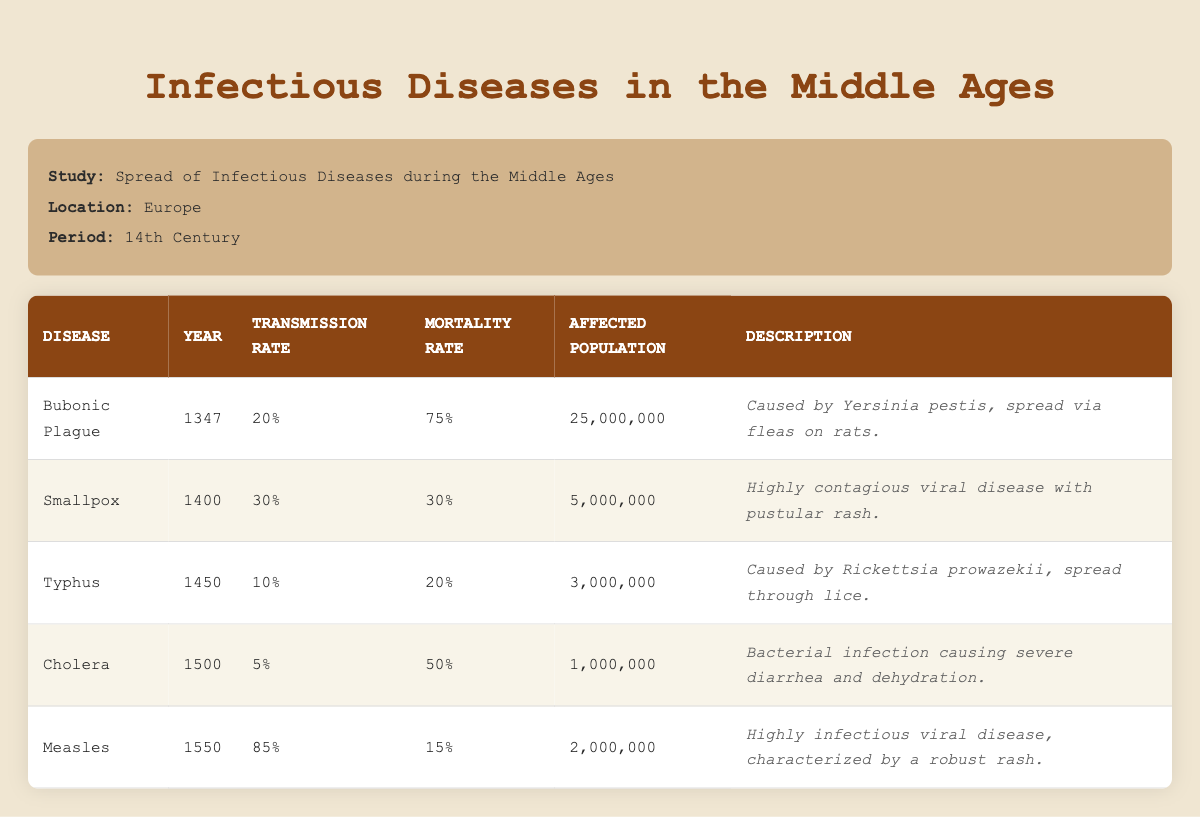What disease had the highest transmission rate during the Middle Ages? Looking at the transmission rates in the table, the disease with the highest transmission rate is Measles at 85%.
Answer: Measles What was the mortality rate of the Bubonic Plague? Referring to the table, the mortality rate for the Bubonic Plague is 75%.
Answer: 75% How many people were affected by Smallpox? The affected population for Smallpox is listed in the table as 5,000,000.
Answer: 5,000,000 Did Typhus have a higher or lower mortality rate than Cholera? Typhus had a mortality rate of 20% while Cholera had a rate of 50%. Since 20% is less than 50%, Typhus had a lower mortality rate than Cholera.
Answer: Lower What is the difference in affected population between the Bubonic Plague and Cholera? The affected population for the Bubonic Plague is 25,000,000 and for Cholera, it is 1,000,000. Calculating the difference: 25,000,000 - 1,000,000 = 24,000,000.
Answer: 24,000,000 What was the average affected population for all diseases listed? To find the average, we need to sum the affected populations: 25,000,000 + 5,000,000 + 3,000,000 + 1,000,000 + 2,000,000 = 36,000,000. There are 5 diseases, so the average is 36,000,000 / 5 = 7,200,000.
Answer: 7,200,000 Was Cholera spread through rats? According to the descriptions in the table, Cholera is a bacterial infection spread causing severe diarrhea and dehydration, but it does not mention rats. Bubonic Plague is noted for spreading via fleas on rats, while Cholera spreads differently through contaminated water. Therefore, the answer is no.
Answer: No Which disease caused more than 20% mortality but less than 30% affected population? Analyzing the table, only Smallpox fits the criteria with a mortality rate of 30% (which precisely matches but doesn't exceed 30%) and affected population of 5,000,000 (less than 20% of the total affected). Therefore, the answer focuses on the mortality aspect which can lead to the interpretation that Smallpox meets the criteria.
Answer: Smallpox Which disease from the table had the least transmission rate? Comparing the transmission rates in the table, Cholera has the lowest at 5%.
Answer: Cholera 